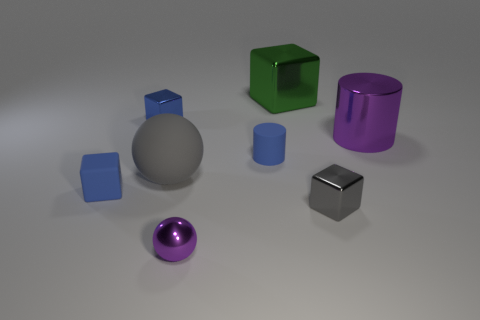Add 1 large gray rubber balls. How many objects exist? 9 Subtract all spheres. How many objects are left? 6 Subtract all large gray things. Subtract all green shiny blocks. How many objects are left? 6 Add 7 small blue cubes. How many small blue cubes are left? 9 Add 8 big rubber things. How many big rubber things exist? 9 Subtract 2 blue blocks. How many objects are left? 6 